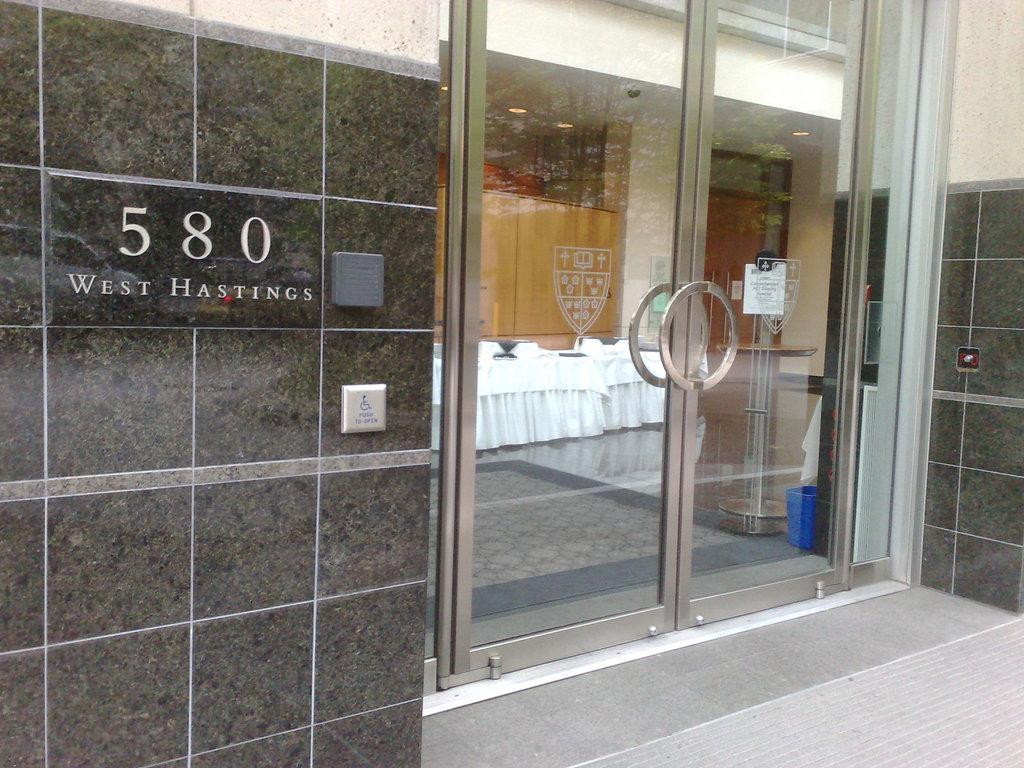Please provide a concise description of this image. In this image there is a building with some text on the wall and there is a glass door through which we can see there are tables and chairs are arranged. 